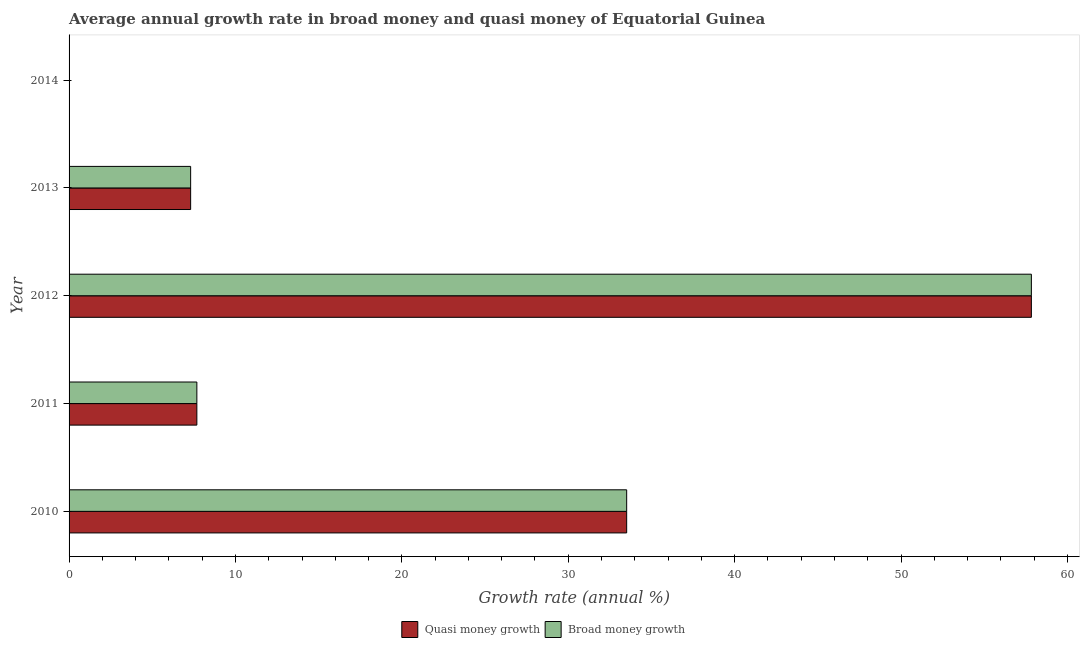How many different coloured bars are there?
Give a very brief answer. 2. Are the number of bars on each tick of the Y-axis equal?
Provide a short and direct response. No. How many bars are there on the 4th tick from the top?
Provide a succinct answer. 2. In how many cases, is the number of bars for a given year not equal to the number of legend labels?
Your answer should be compact. 1. Across all years, what is the maximum annual growth rate in broad money?
Offer a very short reply. 57.83. What is the total annual growth rate in broad money in the graph?
Keep it short and to the point. 106.33. What is the difference between the annual growth rate in quasi money in 2012 and that in 2013?
Your response must be concise. 50.53. What is the difference between the annual growth rate in broad money in 2014 and the annual growth rate in quasi money in 2010?
Your answer should be compact. -33.51. What is the average annual growth rate in quasi money per year?
Ensure brevity in your answer.  21.27. What is the ratio of the annual growth rate in broad money in 2011 to that in 2012?
Ensure brevity in your answer.  0.13. Is the annual growth rate in broad money in 2011 less than that in 2013?
Offer a very short reply. No. Is the difference between the annual growth rate in quasi money in 2010 and 2011 greater than the difference between the annual growth rate in broad money in 2010 and 2011?
Your answer should be compact. No. What is the difference between the highest and the second highest annual growth rate in broad money?
Your answer should be compact. 24.32. What is the difference between the highest and the lowest annual growth rate in quasi money?
Offer a terse response. 57.83. Is the sum of the annual growth rate in quasi money in 2011 and 2013 greater than the maximum annual growth rate in broad money across all years?
Your answer should be very brief. No. How many bars are there?
Provide a short and direct response. 8. Are all the bars in the graph horizontal?
Keep it short and to the point. Yes. How many years are there in the graph?
Give a very brief answer. 5. Are the values on the major ticks of X-axis written in scientific E-notation?
Your answer should be very brief. No. Does the graph contain grids?
Ensure brevity in your answer.  No. Where does the legend appear in the graph?
Your response must be concise. Bottom center. How many legend labels are there?
Ensure brevity in your answer.  2. What is the title of the graph?
Provide a short and direct response. Average annual growth rate in broad money and quasi money of Equatorial Guinea. Does "Arms imports" appear as one of the legend labels in the graph?
Make the answer very short. No. What is the label or title of the X-axis?
Provide a succinct answer. Growth rate (annual %). What is the label or title of the Y-axis?
Provide a succinct answer. Year. What is the Growth rate (annual %) of Quasi money growth in 2010?
Give a very brief answer. 33.51. What is the Growth rate (annual %) in Broad money growth in 2010?
Provide a succinct answer. 33.51. What is the Growth rate (annual %) in Quasi money growth in 2011?
Give a very brief answer. 7.68. What is the Growth rate (annual %) in Broad money growth in 2011?
Your answer should be very brief. 7.68. What is the Growth rate (annual %) in Quasi money growth in 2012?
Make the answer very short. 57.83. What is the Growth rate (annual %) of Broad money growth in 2012?
Offer a terse response. 57.83. What is the Growth rate (annual %) in Quasi money growth in 2013?
Ensure brevity in your answer.  7.31. What is the Growth rate (annual %) in Broad money growth in 2013?
Give a very brief answer. 7.31. What is the Growth rate (annual %) in Quasi money growth in 2014?
Keep it short and to the point. 0. What is the Growth rate (annual %) of Broad money growth in 2014?
Offer a terse response. 0. Across all years, what is the maximum Growth rate (annual %) in Quasi money growth?
Offer a very short reply. 57.83. Across all years, what is the maximum Growth rate (annual %) of Broad money growth?
Give a very brief answer. 57.83. Across all years, what is the minimum Growth rate (annual %) of Quasi money growth?
Make the answer very short. 0. Across all years, what is the minimum Growth rate (annual %) in Broad money growth?
Keep it short and to the point. 0. What is the total Growth rate (annual %) in Quasi money growth in the graph?
Your answer should be very brief. 106.33. What is the total Growth rate (annual %) in Broad money growth in the graph?
Your response must be concise. 106.33. What is the difference between the Growth rate (annual %) of Quasi money growth in 2010 and that in 2011?
Offer a very short reply. 25.83. What is the difference between the Growth rate (annual %) of Broad money growth in 2010 and that in 2011?
Provide a succinct answer. 25.83. What is the difference between the Growth rate (annual %) in Quasi money growth in 2010 and that in 2012?
Provide a succinct answer. -24.32. What is the difference between the Growth rate (annual %) in Broad money growth in 2010 and that in 2012?
Keep it short and to the point. -24.32. What is the difference between the Growth rate (annual %) in Quasi money growth in 2010 and that in 2013?
Offer a very short reply. 26.2. What is the difference between the Growth rate (annual %) of Broad money growth in 2010 and that in 2013?
Keep it short and to the point. 26.2. What is the difference between the Growth rate (annual %) of Quasi money growth in 2011 and that in 2012?
Provide a short and direct response. -50.15. What is the difference between the Growth rate (annual %) of Broad money growth in 2011 and that in 2012?
Offer a very short reply. -50.15. What is the difference between the Growth rate (annual %) in Quasi money growth in 2011 and that in 2013?
Your answer should be compact. 0.37. What is the difference between the Growth rate (annual %) of Broad money growth in 2011 and that in 2013?
Provide a succinct answer. 0.37. What is the difference between the Growth rate (annual %) of Quasi money growth in 2012 and that in 2013?
Keep it short and to the point. 50.53. What is the difference between the Growth rate (annual %) in Broad money growth in 2012 and that in 2013?
Provide a succinct answer. 50.53. What is the difference between the Growth rate (annual %) of Quasi money growth in 2010 and the Growth rate (annual %) of Broad money growth in 2011?
Provide a succinct answer. 25.83. What is the difference between the Growth rate (annual %) in Quasi money growth in 2010 and the Growth rate (annual %) in Broad money growth in 2012?
Provide a succinct answer. -24.32. What is the difference between the Growth rate (annual %) of Quasi money growth in 2010 and the Growth rate (annual %) of Broad money growth in 2013?
Offer a terse response. 26.2. What is the difference between the Growth rate (annual %) of Quasi money growth in 2011 and the Growth rate (annual %) of Broad money growth in 2012?
Offer a very short reply. -50.15. What is the difference between the Growth rate (annual %) of Quasi money growth in 2011 and the Growth rate (annual %) of Broad money growth in 2013?
Provide a succinct answer. 0.37. What is the difference between the Growth rate (annual %) in Quasi money growth in 2012 and the Growth rate (annual %) in Broad money growth in 2013?
Your response must be concise. 50.53. What is the average Growth rate (annual %) in Quasi money growth per year?
Provide a succinct answer. 21.27. What is the average Growth rate (annual %) in Broad money growth per year?
Your response must be concise. 21.27. In the year 2011, what is the difference between the Growth rate (annual %) of Quasi money growth and Growth rate (annual %) of Broad money growth?
Ensure brevity in your answer.  0. In the year 2013, what is the difference between the Growth rate (annual %) in Quasi money growth and Growth rate (annual %) in Broad money growth?
Provide a short and direct response. 0. What is the ratio of the Growth rate (annual %) of Quasi money growth in 2010 to that in 2011?
Give a very brief answer. 4.36. What is the ratio of the Growth rate (annual %) of Broad money growth in 2010 to that in 2011?
Provide a succinct answer. 4.36. What is the ratio of the Growth rate (annual %) in Quasi money growth in 2010 to that in 2012?
Make the answer very short. 0.58. What is the ratio of the Growth rate (annual %) in Broad money growth in 2010 to that in 2012?
Keep it short and to the point. 0.58. What is the ratio of the Growth rate (annual %) in Quasi money growth in 2010 to that in 2013?
Give a very brief answer. 4.59. What is the ratio of the Growth rate (annual %) of Broad money growth in 2010 to that in 2013?
Give a very brief answer. 4.59. What is the ratio of the Growth rate (annual %) in Quasi money growth in 2011 to that in 2012?
Keep it short and to the point. 0.13. What is the ratio of the Growth rate (annual %) of Broad money growth in 2011 to that in 2012?
Make the answer very short. 0.13. What is the ratio of the Growth rate (annual %) in Quasi money growth in 2011 to that in 2013?
Make the answer very short. 1.05. What is the ratio of the Growth rate (annual %) of Broad money growth in 2011 to that in 2013?
Ensure brevity in your answer.  1.05. What is the ratio of the Growth rate (annual %) of Quasi money growth in 2012 to that in 2013?
Keep it short and to the point. 7.92. What is the ratio of the Growth rate (annual %) of Broad money growth in 2012 to that in 2013?
Make the answer very short. 7.92. What is the difference between the highest and the second highest Growth rate (annual %) of Quasi money growth?
Offer a terse response. 24.32. What is the difference between the highest and the second highest Growth rate (annual %) of Broad money growth?
Provide a succinct answer. 24.32. What is the difference between the highest and the lowest Growth rate (annual %) in Quasi money growth?
Offer a terse response. 57.83. What is the difference between the highest and the lowest Growth rate (annual %) in Broad money growth?
Your response must be concise. 57.83. 